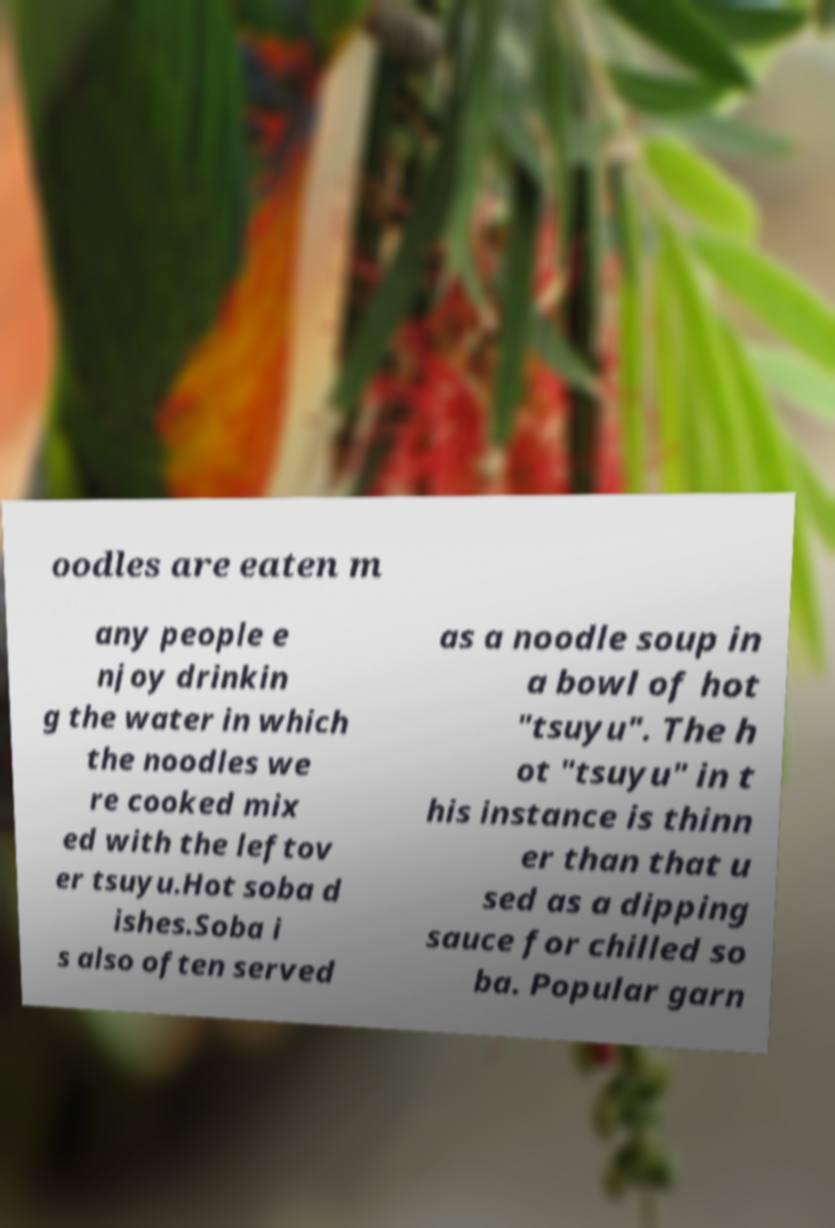There's text embedded in this image that I need extracted. Can you transcribe it verbatim? oodles are eaten m any people e njoy drinkin g the water in which the noodles we re cooked mix ed with the leftov er tsuyu.Hot soba d ishes.Soba i s also often served as a noodle soup in a bowl of hot "tsuyu". The h ot "tsuyu" in t his instance is thinn er than that u sed as a dipping sauce for chilled so ba. Popular garn 